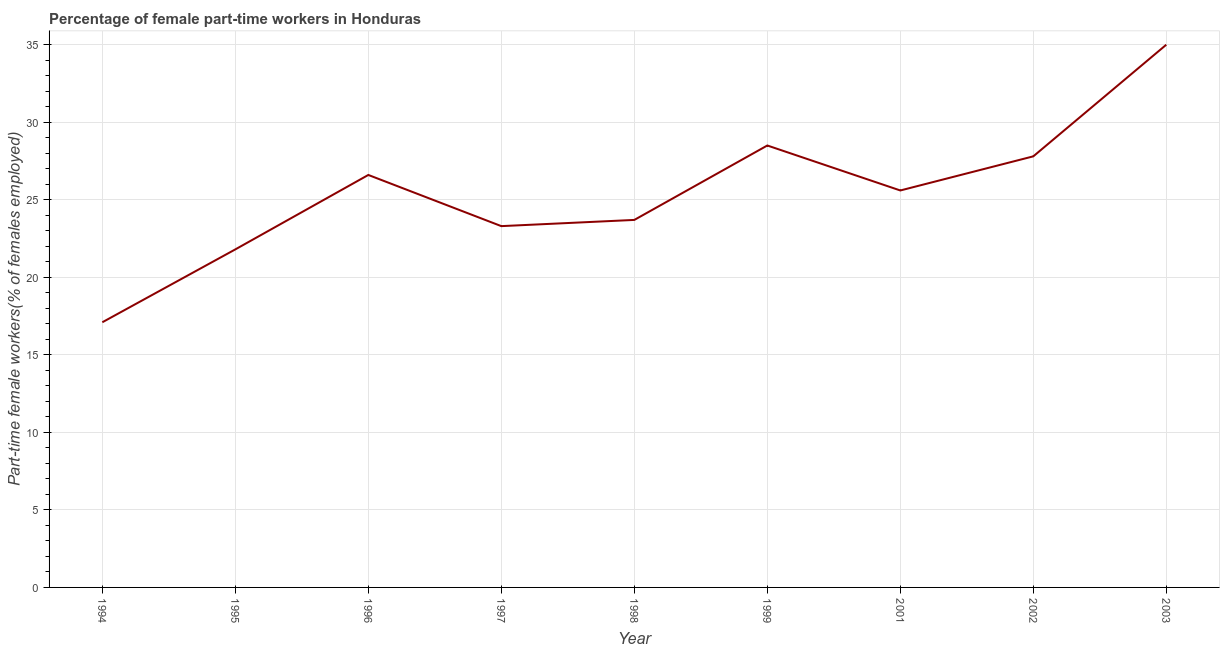What is the percentage of part-time female workers in 1994?
Provide a succinct answer. 17.1. Across all years, what is the maximum percentage of part-time female workers?
Ensure brevity in your answer.  35. Across all years, what is the minimum percentage of part-time female workers?
Keep it short and to the point. 17.1. In which year was the percentage of part-time female workers minimum?
Give a very brief answer. 1994. What is the sum of the percentage of part-time female workers?
Make the answer very short. 229.4. What is the average percentage of part-time female workers per year?
Keep it short and to the point. 25.49. What is the median percentage of part-time female workers?
Your answer should be compact. 25.6. What is the ratio of the percentage of part-time female workers in 1995 to that in 1997?
Provide a short and direct response. 0.94. Is the percentage of part-time female workers in 1996 less than that in 2003?
Your answer should be compact. Yes. Is the difference between the percentage of part-time female workers in 1994 and 2001 greater than the difference between any two years?
Your answer should be very brief. No. Is the sum of the percentage of part-time female workers in 1998 and 1999 greater than the maximum percentage of part-time female workers across all years?
Your response must be concise. Yes. What is the difference between the highest and the lowest percentage of part-time female workers?
Ensure brevity in your answer.  17.9. How many lines are there?
Provide a short and direct response. 1. What is the difference between two consecutive major ticks on the Y-axis?
Give a very brief answer. 5. Does the graph contain grids?
Ensure brevity in your answer.  Yes. What is the title of the graph?
Keep it short and to the point. Percentage of female part-time workers in Honduras. What is the label or title of the Y-axis?
Offer a terse response. Part-time female workers(% of females employed). What is the Part-time female workers(% of females employed) of 1994?
Offer a very short reply. 17.1. What is the Part-time female workers(% of females employed) of 1995?
Make the answer very short. 21.8. What is the Part-time female workers(% of females employed) in 1996?
Provide a short and direct response. 26.6. What is the Part-time female workers(% of females employed) in 1997?
Your answer should be compact. 23.3. What is the Part-time female workers(% of females employed) in 1998?
Offer a very short reply. 23.7. What is the Part-time female workers(% of females employed) in 1999?
Make the answer very short. 28.5. What is the Part-time female workers(% of females employed) of 2001?
Offer a terse response. 25.6. What is the Part-time female workers(% of females employed) in 2002?
Your response must be concise. 27.8. What is the difference between the Part-time female workers(% of females employed) in 1994 and 2001?
Your answer should be very brief. -8.5. What is the difference between the Part-time female workers(% of females employed) in 1994 and 2002?
Provide a succinct answer. -10.7. What is the difference between the Part-time female workers(% of females employed) in 1994 and 2003?
Make the answer very short. -17.9. What is the difference between the Part-time female workers(% of females employed) in 1995 and 1996?
Provide a succinct answer. -4.8. What is the difference between the Part-time female workers(% of females employed) in 1995 and 1998?
Make the answer very short. -1.9. What is the difference between the Part-time female workers(% of females employed) in 1995 and 1999?
Keep it short and to the point. -6.7. What is the difference between the Part-time female workers(% of females employed) in 1995 and 2002?
Provide a succinct answer. -6. What is the difference between the Part-time female workers(% of females employed) in 1996 and 1997?
Make the answer very short. 3.3. What is the difference between the Part-time female workers(% of females employed) in 1996 and 1998?
Give a very brief answer. 2.9. What is the difference between the Part-time female workers(% of females employed) in 1996 and 1999?
Your answer should be very brief. -1.9. What is the difference between the Part-time female workers(% of females employed) in 1996 and 2002?
Give a very brief answer. -1.2. What is the difference between the Part-time female workers(% of females employed) in 1997 and 1999?
Your answer should be very brief. -5.2. What is the difference between the Part-time female workers(% of females employed) in 1997 and 2002?
Give a very brief answer. -4.5. What is the difference between the Part-time female workers(% of females employed) in 1997 and 2003?
Give a very brief answer. -11.7. What is the difference between the Part-time female workers(% of females employed) in 1998 and 2002?
Provide a succinct answer. -4.1. What is the difference between the Part-time female workers(% of females employed) in 1998 and 2003?
Provide a short and direct response. -11.3. What is the difference between the Part-time female workers(% of females employed) in 1999 and 2002?
Provide a succinct answer. 0.7. What is the difference between the Part-time female workers(% of females employed) in 1999 and 2003?
Give a very brief answer. -6.5. What is the difference between the Part-time female workers(% of females employed) in 2001 and 2003?
Offer a very short reply. -9.4. What is the ratio of the Part-time female workers(% of females employed) in 1994 to that in 1995?
Offer a very short reply. 0.78. What is the ratio of the Part-time female workers(% of females employed) in 1994 to that in 1996?
Provide a succinct answer. 0.64. What is the ratio of the Part-time female workers(% of females employed) in 1994 to that in 1997?
Provide a short and direct response. 0.73. What is the ratio of the Part-time female workers(% of females employed) in 1994 to that in 1998?
Your answer should be compact. 0.72. What is the ratio of the Part-time female workers(% of females employed) in 1994 to that in 1999?
Provide a short and direct response. 0.6. What is the ratio of the Part-time female workers(% of females employed) in 1994 to that in 2001?
Your answer should be very brief. 0.67. What is the ratio of the Part-time female workers(% of females employed) in 1994 to that in 2002?
Make the answer very short. 0.61. What is the ratio of the Part-time female workers(% of females employed) in 1994 to that in 2003?
Your answer should be very brief. 0.49. What is the ratio of the Part-time female workers(% of females employed) in 1995 to that in 1996?
Your answer should be very brief. 0.82. What is the ratio of the Part-time female workers(% of females employed) in 1995 to that in 1997?
Keep it short and to the point. 0.94. What is the ratio of the Part-time female workers(% of females employed) in 1995 to that in 1999?
Make the answer very short. 0.77. What is the ratio of the Part-time female workers(% of females employed) in 1995 to that in 2001?
Make the answer very short. 0.85. What is the ratio of the Part-time female workers(% of females employed) in 1995 to that in 2002?
Offer a terse response. 0.78. What is the ratio of the Part-time female workers(% of females employed) in 1995 to that in 2003?
Offer a terse response. 0.62. What is the ratio of the Part-time female workers(% of females employed) in 1996 to that in 1997?
Keep it short and to the point. 1.14. What is the ratio of the Part-time female workers(% of females employed) in 1996 to that in 1998?
Offer a very short reply. 1.12. What is the ratio of the Part-time female workers(% of females employed) in 1996 to that in 1999?
Provide a short and direct response. 0.93. What is the ratio of the Part-time female workers(% of females employed) in 1996 to that in 2001?
Ensure brevity in your answer.  1.04. What is the ratio of the Part-time female workers(% of females employed) in 1996 to that in 2003?
Your answer should be compact. 0.76. What is the ratio of the Part-time female workers(% of females employed) in 1997 to that in 1998?
Provide a succinct answer. 0.98. What is the ratio of the Part-time female workers(% of females employed) in 1997 to that in 1999?
Keep it short and to the point. 0.82. What is the ratio of the Part-time female workers(% of females employed) in 1997 to that in 2001?
Ensure brevity in your answer.  0.91. What is the ratio of the Part-time female workers(% of females employed) in 1997 to that in 2002?
Your answer should be very brief. 0.84. What is the ratio of the Part-time female workers(% of females employed) in 1997 to that in 2003?
Keep it short and to the point. 0.67. What is the ratio of the Part-time female workers(% of females employed) in 1998 to that in 1999?
Provide a succinct answer. 0.83. What is the ratio of the Part-time female workers(% of females employed) in 1998 to that in 2001?
Give a very brief answer. 0.93. What is the ratio of the Part-time female workers(% of females employed) in 1998 to that in 2002?
Give a very brief answer. 0.85. What is the ratio of the Part-time female workers(% of females employed) in 1998 to that in 2003?
Offer a terse response. 0.68. What is the ratio of the Part-time female workers(% of females employed) in 1999 to that in 2001?
Your answer should be compact. 1.11. What is the ratio of the Part-time female workers(% of females employed) in 1999 to that in 2003?
Offer a very short reply. 0.81. What is the ratio of the Part-time female workers(% of females employed) in 2001 to that in 2002?
Give a very brief answer. 0.92. What is the ratio of the Part-time female workers(% of females employed) in 2001 to that in 2003?
Provide a short and direct response. 0.73. What is the ratio of the Part-time female workers(% of females employed) in 2002 to that in 2003?
Provide a succinct answer. 0.79. 